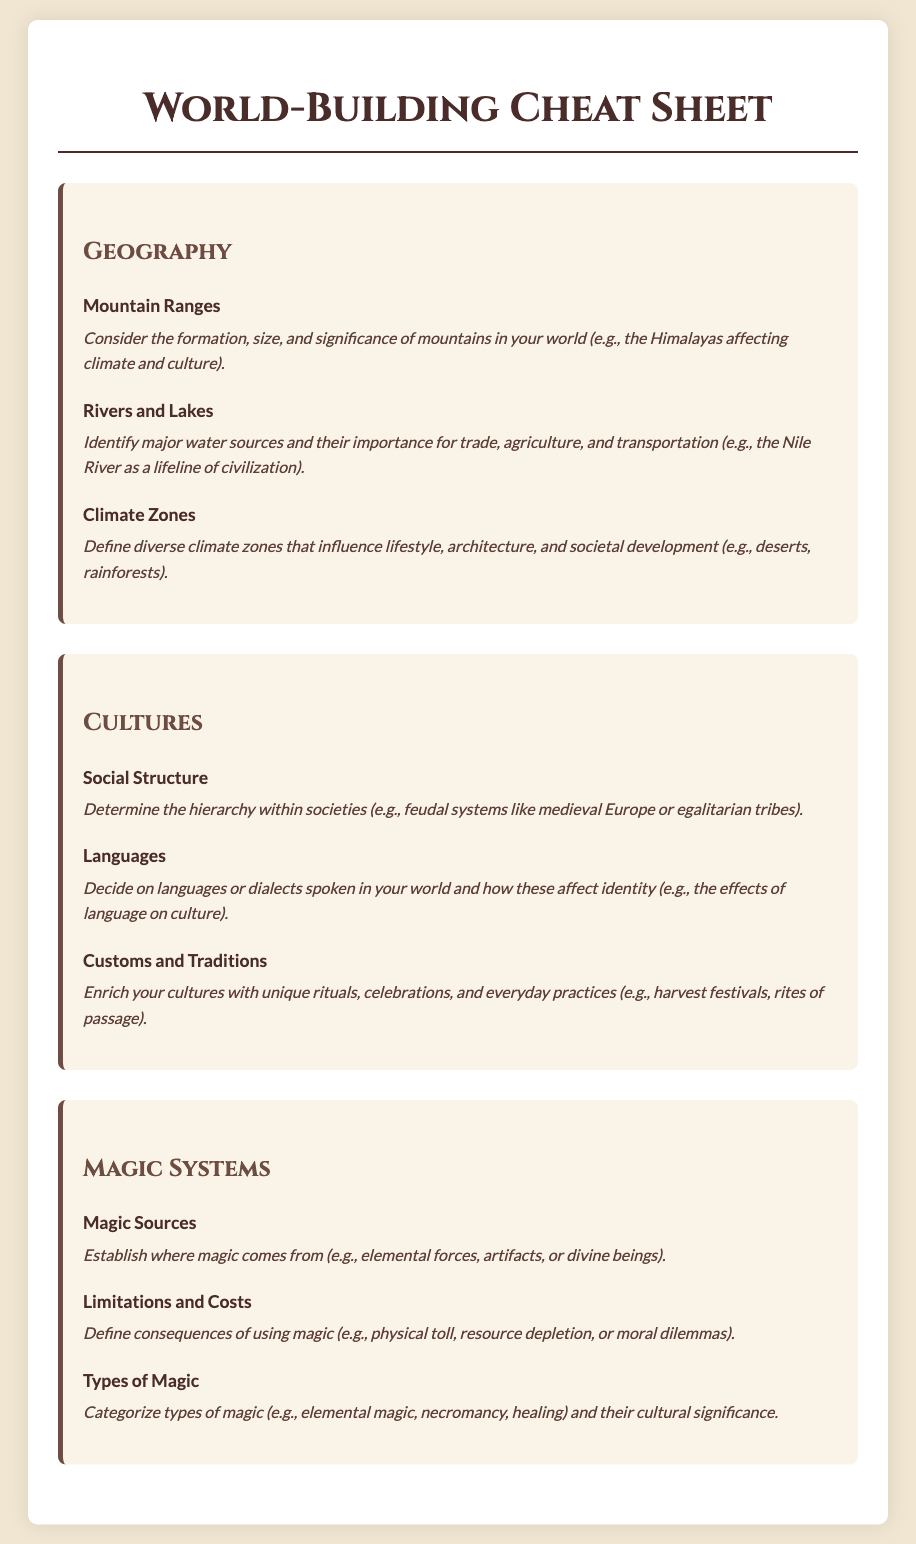What are the key elements of geography? The section titled 'Geography' outlines elements such as Mountain Ranges, Rivers and Lakes, and Climate Zones.
Answer: Mountain Ranges, Rivers and Lakes, Climate Zones What is considered a major water source? The description of Rivers and Lakes highlights their significance for trade, agriculture, and transportation, using the Nile River as an example.
Answer: Nile River What defines social structure in cultures? The document states that social structure can include hierarchies within societies, such as feudal systems or egalitarian tribes.
Answer: Hierarchies What are the types of magic mentioned? The section on Magic Systems categorizes magic, with examples including elemental magic, necromancy, and healing.
Answer: Elemental magic, necromancy, healing What influences lifestyle according to climate zones? The document describes that different climate zones affect lifestyle, architecture, and societal development.
Answer: Lifestyle, architecture, societal development What is a unique cultural practice mentioned? The Customs and Traditions element discusses unique rituals or celebrations, providing "harvest festivals" as an example.
Answer: Harvest festivals What determines the consequences of using magic? The Limitations and Costs section specifies defining consequences like physical toll or resource depletion.
Answer: Physical toll Where does magic come from? The Magic Sources element establishes magic can come from elemental forces, artifacts, or divine beings.
Answer: Elemental forces, artifacts, divine beings 